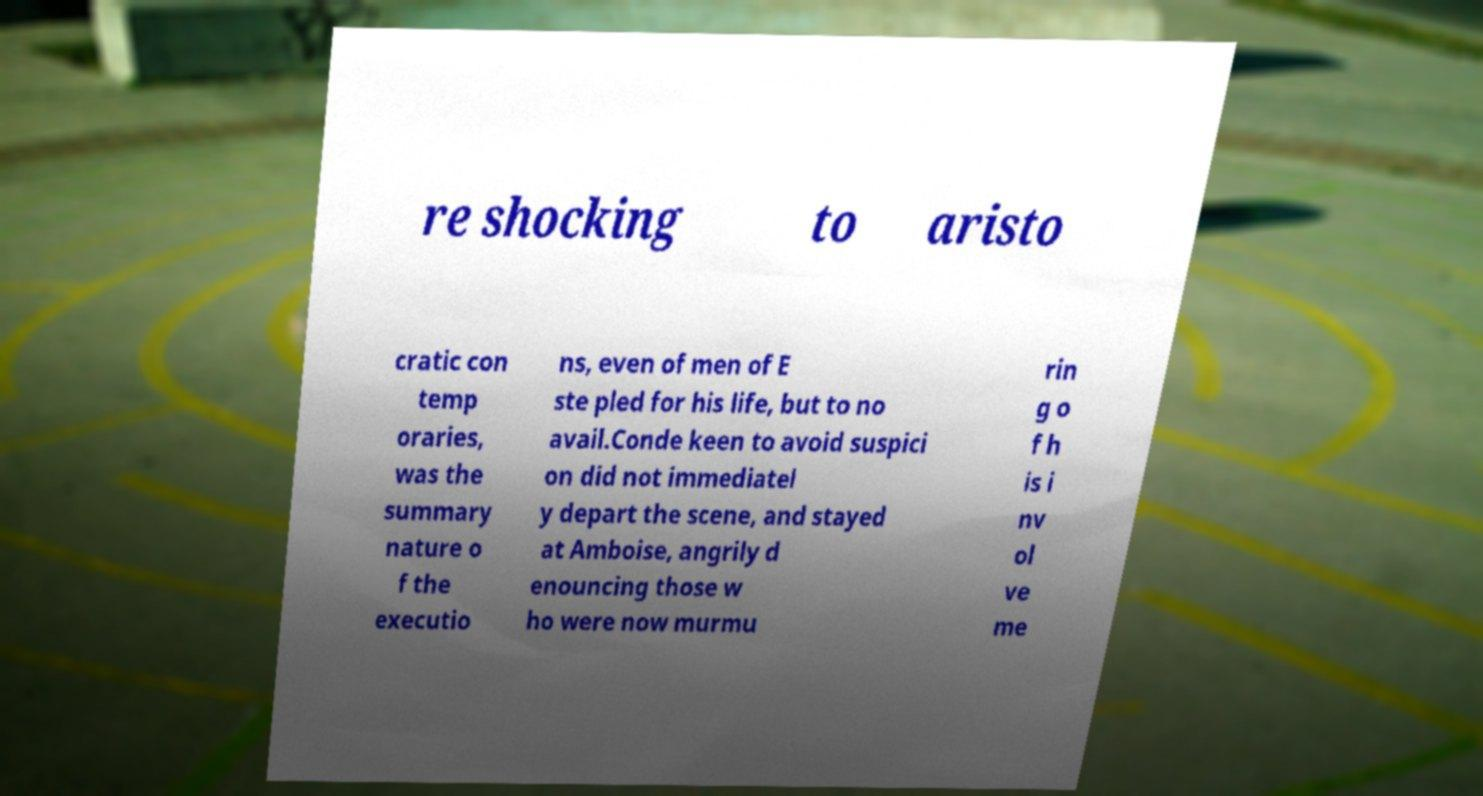I need the written content from this picture converted into text. Can you do that? re shocking to aristo cratic con temp oraries, was the summary nature o f the executio ns, even of men of E ste pled for his life, but to no avail.Conde keen to avoid suspici on did not immediatel y depart the scene, and stayed at Amboise, angrily d enouncing those w ho were now murmu rin g o f h is i nv ol ve me 